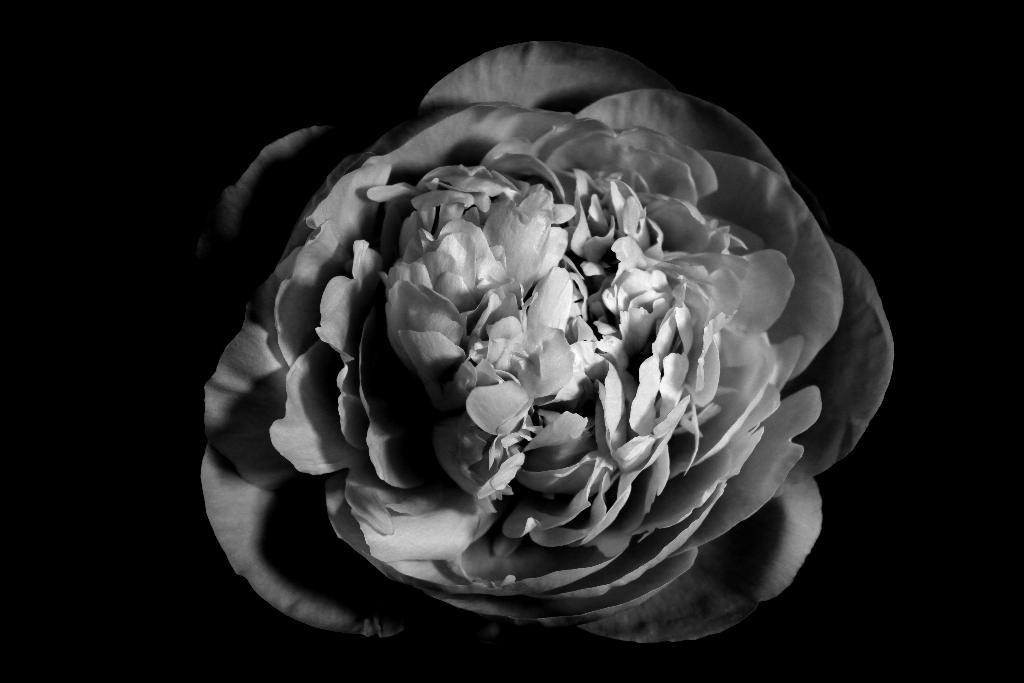What is the main subject of the image? There is a flower in the image. Can you describe the background of the image? The background of the image is dark. What type of crown is the flower wearing in the image? There is no crown present in the image; it features a flower without any accessories. What type of action is the flower performing in the image? The flower is not performing any action in the image, as it is a static object. 